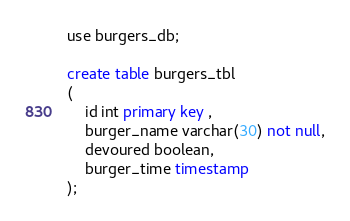Convert code to text. <code><loc_0><loc_0><loc_500><loc_500><_SQL_>
use burgers_db;

create table burgers_tbl
(
    id int primary key ,
    burger_name varchar(30) not null,
    devoured boolean,
    burger_time timestamp
);</code> 